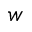Convert formula to latex. <formula><loc_0><loc_0><loc_500><loc_500>w</formula> 